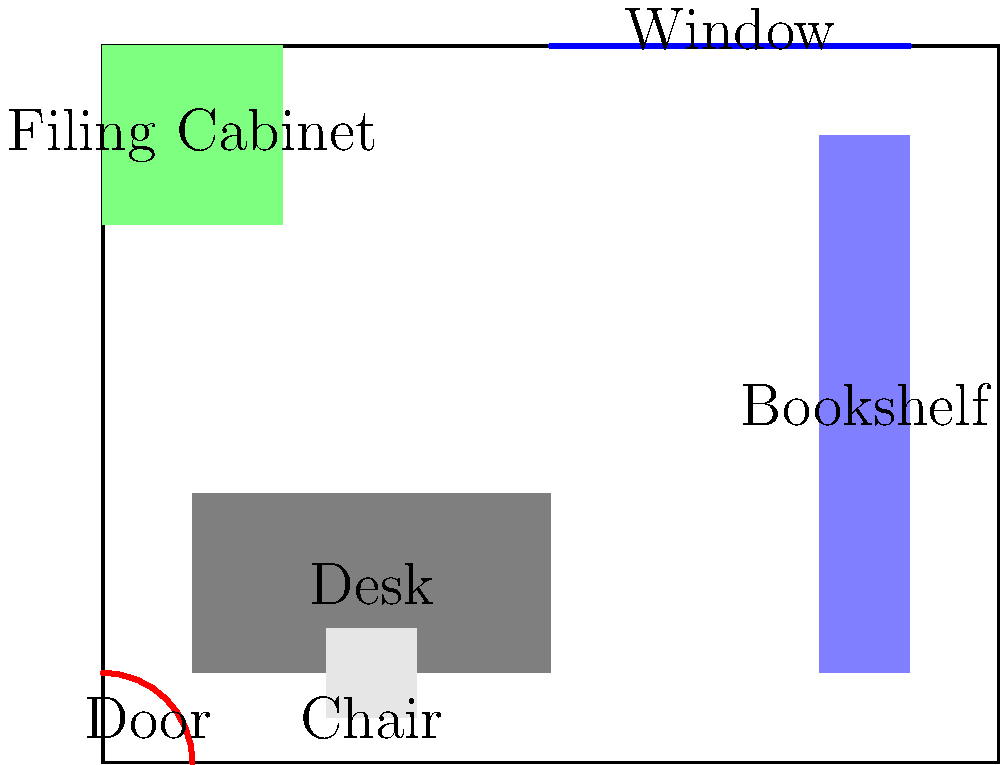As a financial consultant working from home, you need to optimize your small office space for efficiency. Given the layout shown, which arrangement allows for the best use of natural light and easy access to essential items while maximizing floor space? To determine the most efficient arrangement, we need to consider several factors:

1. Natural light: The window is located on the top wall, so placing the desk near it would maximize natural light exposure.

2. Accessibility: The filing cabinet and bookshelf should be easily accessible from the desk for quick reference to important documents.

3. Floor space: Keeping the center of the room clear allows for easy movement and makes the space feel larger.

4. Door clearance: Ensure that the door can open fully without obstruction.

Analyzing the current layout:

1. The desk is placed centrally, which doesn't take full advantage of natural light from the window.
2. The filing cabinet is in the corner opposite the door, which may not be the most accessible location.
3. The bookshelf is well-placed along the right wall, providing easy access and using vertical space efficiently.
4. The chair is correctly positioned in front of the desk.

An optimized arrangement would be:

1. Move the desk to the top wall, directly under the window. This maximizes natural light and creates a focal point.
2. Place the chair in front of the desk, facing the window.
3. Move the filing cabinet to the left wall, closer to the desk for easy access.
4. Keep the bookshelf in its current position on the right wall.

This arrangement would:
- Maximize natural light usage
- Improve accessibility to essential items
- Create an open floor space in the center of the room
- Maintain clear access to the door
Answer: Desk under window, filing cabinet on left wall, bookshelf on right wall 